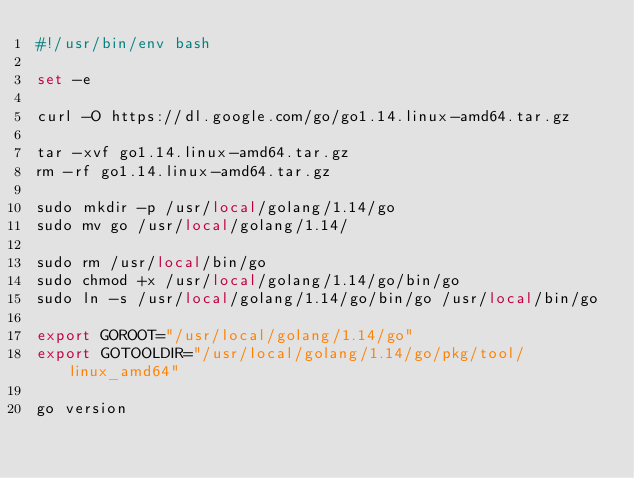Convert code to text. <code><loc_0><loc_0><loc_500><loc_500><_Bash_>#!/usr/bin/env bash

set -e

curl -O https://dl.google.com/go/go1.14.linux-amd64.tar.gz

tar -xvf go1.14.linux-amd64.tar.gz
rm -rf go1.14.linux-amd64.tar.gz

sudo mkdir -p /usr/local/golang/1.14/go
sudo mv go /usr/local/golang/1.14/

sudo rm /usr/local/bin/go
sudo chmod +x /usr/local/golang/1.14/go/bin/go
sudo ln -s /usr/local/golang/1.14/go/bin/go /usr/local/bin/go

export GOROOT="/usr/local/golang/1.14/go"
export GOTOOLDIR="/usr/local/golang/1.14/go/pkg/tool/linux_amd64"

go version
</code> 